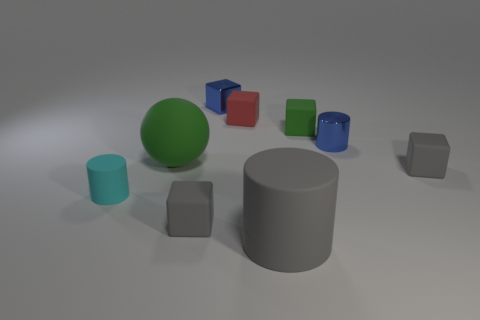Subtract all matte cylinders. How many cylinders are left? 1 Subtract all purple blocks. Subtract all red cylinders. How many blocks are left? 5 Subtract all green balls. How many blue cylinders are left? 1 Subtract all small shiny balls. Subtract all tiny rubber cylinders. How many objects are left? 8 Add 2 metal things. How many metal things are left? 4 Add 6 large green matte things. How many large green matte things exist? 7 Add 1 cyan things. How many objects exist? 10 Subtract all gray cylinders. How many cylinders are left? 2 Subtract 0 red balls. How many objects are left? 9 Subtract all balls. How many objects are left? 8 